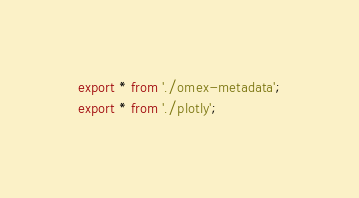Convert code to text. <code><loc_0><loc_0><loc_500><loc_500><_TypeScript_>export * from './omex-metadata';
export * from './plotly';
</code> 